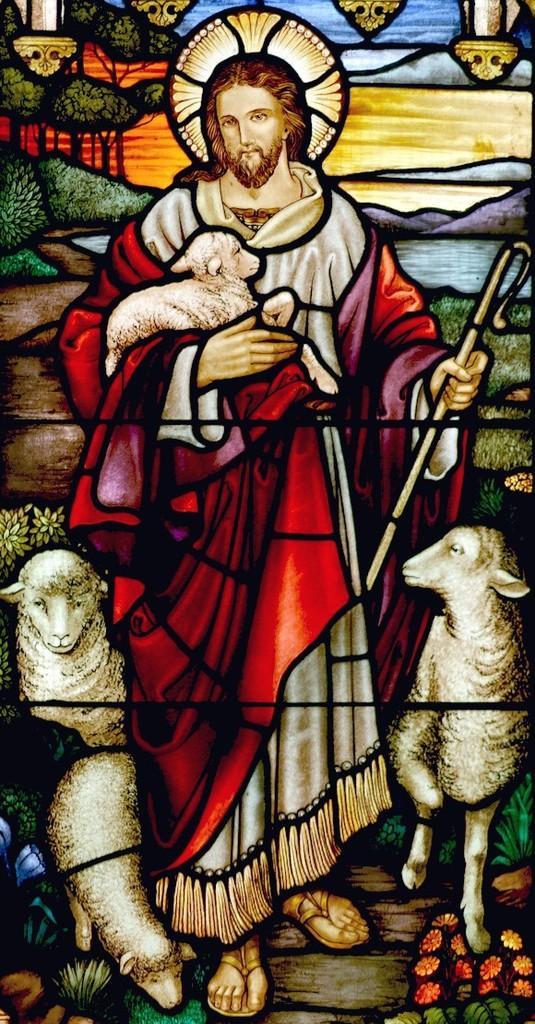Please provide a concise description of this image. In this image I can see depiction of few sheep and of a man. I can also see depictions of few other things. 